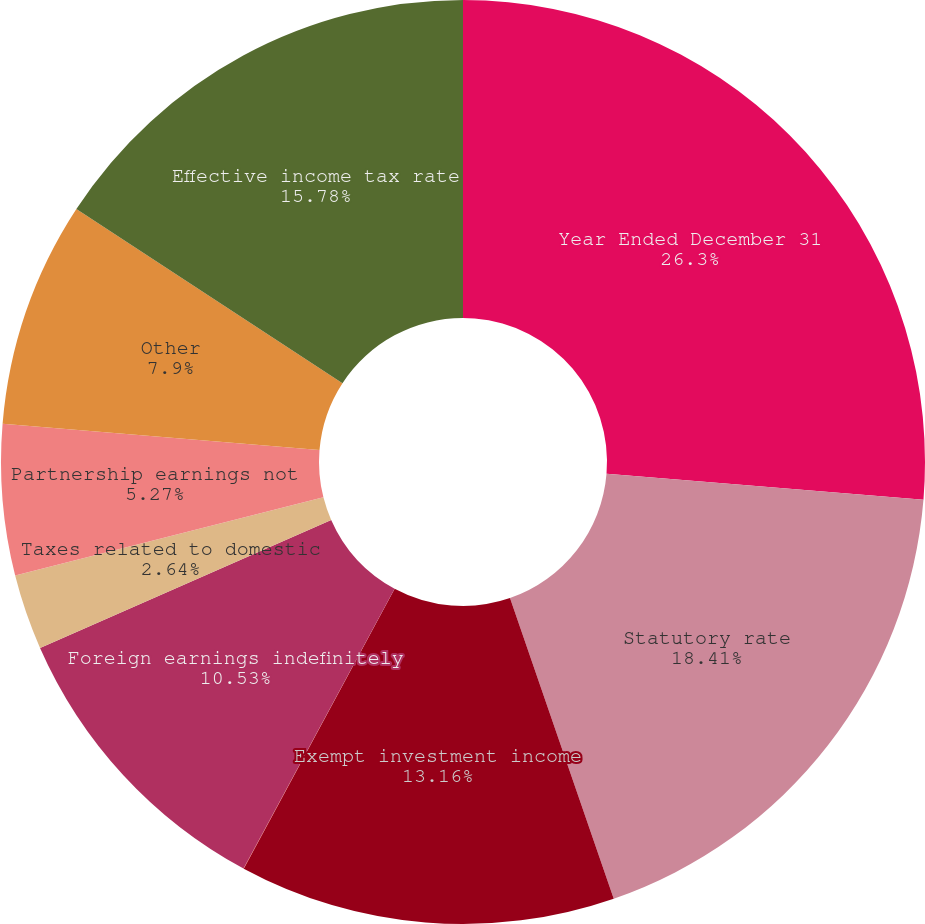<chart> <loc_0><loc_0><loc_500><loc_500><pie_chart><fcel>Year Ended December 31<fcel>Statutory rate<fcel>Exempt investment income<fcel>State and city income taxes<fcel>Foreign earnings indefinitely<fcel>Taxes related to domestic<fcel>Partnership earnings not<fcel>Other<fcel>Effective income tax rate<nl><fcel>26.3%<fcel>18.41%<fcel>13.16%<fcel>0.01%<fcel>10.53%<fcel>2.64%<fcel>5.27%<fcel>7.9%<fcel>15.78%<nl></chart> 